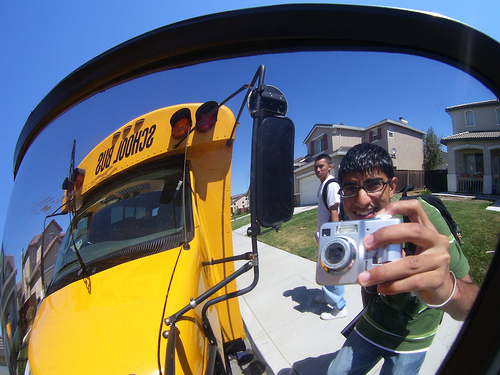Please provide the bounding box coordinate of the region this sentence describes: the camera is silver. The bounding box for the region described by 'the camera is silver' is [0.62, 0.56, 0.81, 0.7]. 